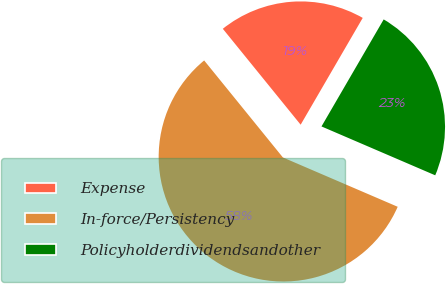Convert chart. <chart><loc_0><loc_0><loc_500><loc_500><pie_chart><fcel>Expense<fcel>In-force/Persistency<fcel>Policyholderdividendsandother<nl><fcel>19.23%<fcel>57.69%<fcel>23.08%<nl></chart> 